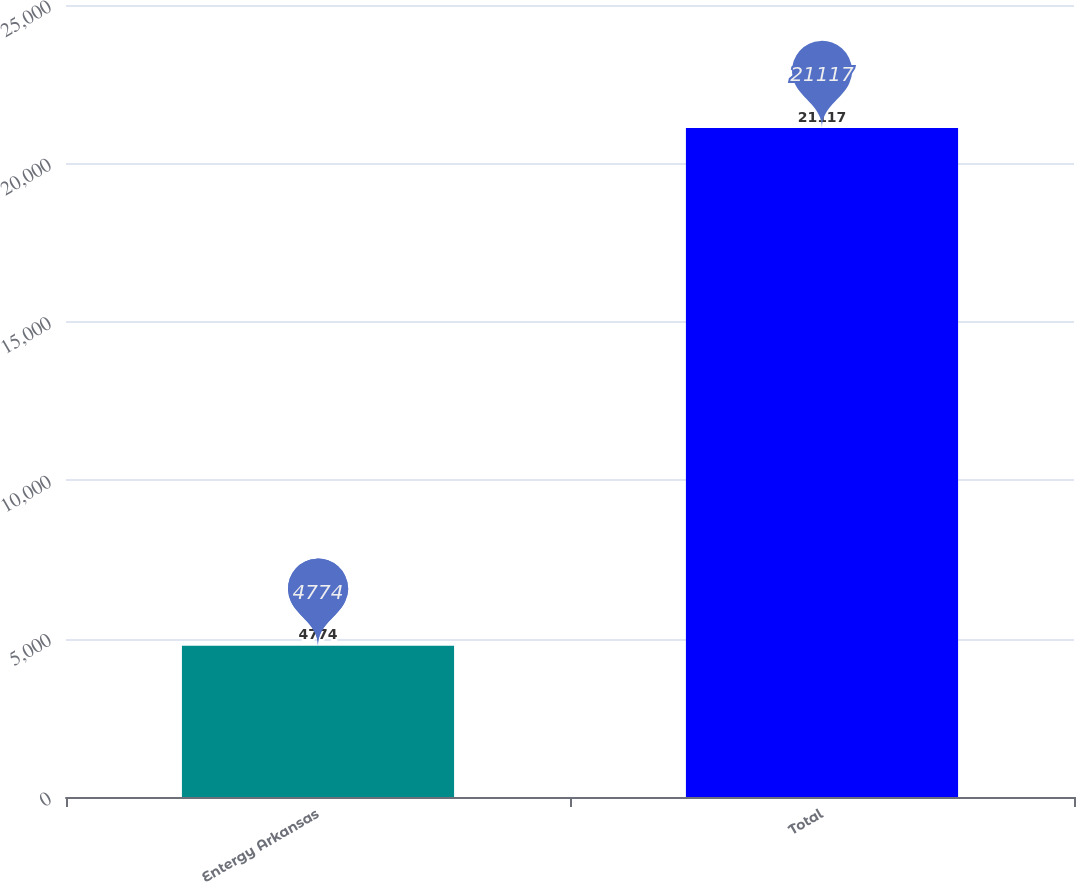Convert chart to OTSL. <chart><loc_0><loc_0><loc_500><loc_500><bar_chart><fcel>Entergy Arkansas<fcel>Total<nl><fcel>4774<fcel>21117<nl></chart> 